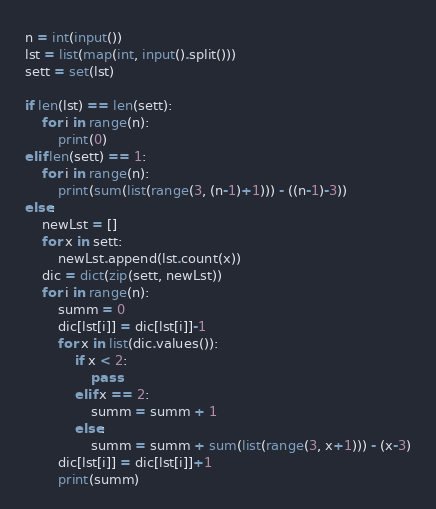Convert code to text. <code><loc_0><loc_0><loc_500><loc_500><_Python_>n = int(input())
lst = list(map(int, input().split()))
sett = set(lst)

if len(lst) == len(sett):
    for i in range(n):
        print(0)
elif len(sett) == 1:
    for i in range(n):
        print(sum(list(range(3, (n-1)+1))) - ((n-1)-3))
else:
    newLst = []
    for x in sett:
        newLst.append(lst.count(x))
    dic = dict(zip(sett, newLst))
    for i in range(n):
        summ = 0
        dic[lst[i]] = dic[lst[i]]-1
        for x in list(dic.values()):
            if x < 2:
                pass
            elif x == 2:
                summ = summ + 1
            else:
                summ = summ + sum(list(range(3, x+1))) - (x-3)
        dic[lst[i]] = dic[lst[i]]+1
        print(summ)
</code> 